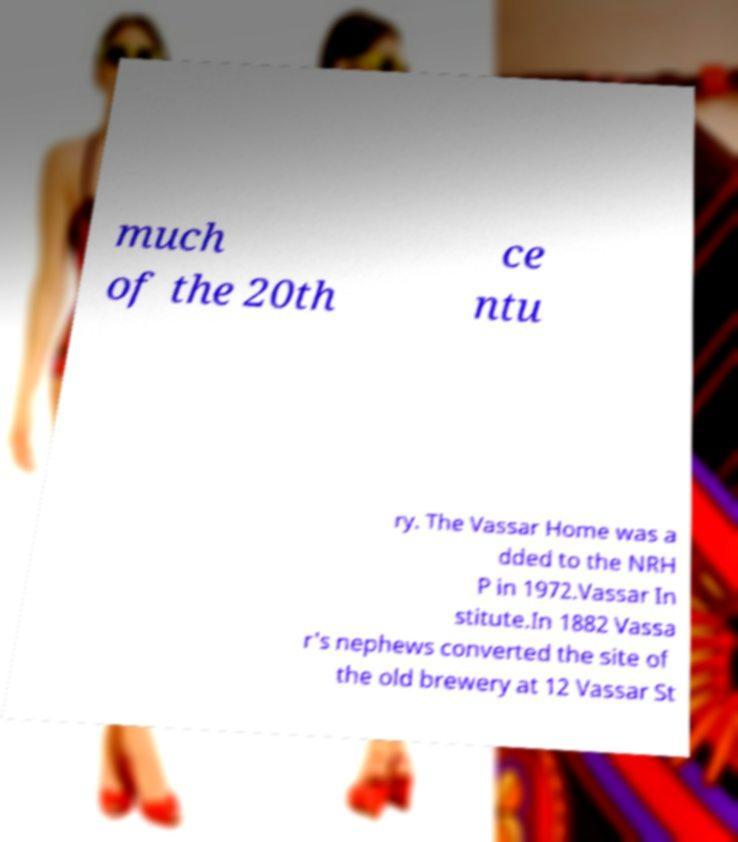Could you assist in decoding the text presented in this image and type it out clearly? much of the 20th ce ntu ry. The Vassar Home was a dded to the NRH P in 1972.Vassar In stitute.In 1882 Vassa r's nephews converted the site of the old brewery at 12 Vassar St 